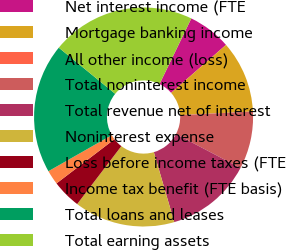Convert chart to OTSL. <chart><loc_0><loc_0><loc_500><loc_500><pie_chart><fcel>Net interest income (FTE<fcel>Mortgage banking income<fcel>All other income (loss)<fcel>Total noninterest income<fcel>Total revenue net of interest<fcel>Noninterest expense<fcel>Loss before income taxes (FTE<fcel>Income tax benefit (FTE basis)<fcel>Total loans and leases<fcel>Total earning assets<nl><fcel>6.38%<fcel>10.64%<fcel>0.0%<fcel>8.51%<fcel>12.77%<fcel>14.89%<fcel>4.26%<fcel>2.13%<fcel>19.15%<fcel>21.27%<nl></chart> 